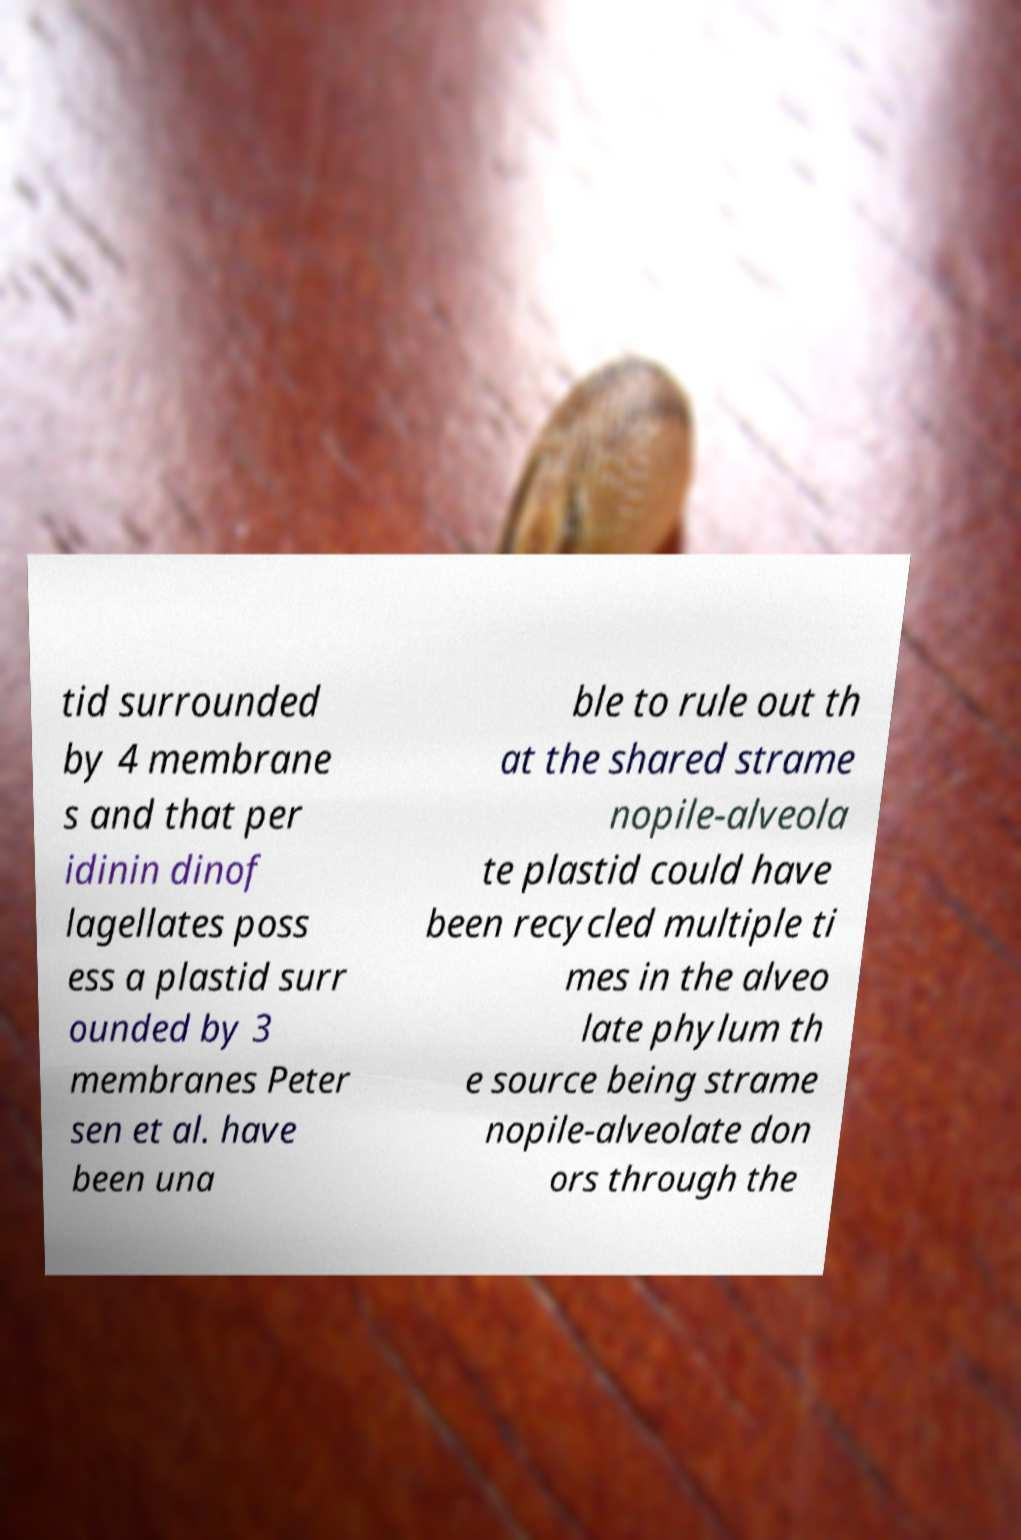Could you extract and type out the text from this image? tid surrounded by 4 membrane s and that per idinin dinof lagellates poss ess a plastid surr ounded by 3 membranes Peter sen et al. have been una ble to rule out th at the shared strame nopile-alveola te plastid could have been recycled multiple ti mes in the alveo late phylum th e source being strame nopile-alveolate don ors through the 